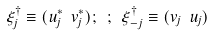Convert formula to latex. <formula><loc_0><loc_0><loc_500><loc_500>\xi ^ { \dag } _ { j } \equiv ( u ^ { * } _ { j } \ v ^ { * } _ { j } ) ; \ ; \ \xi ^ { \dag } _ { - j } \equiv ( v _ { j } \ u _ { j } )</formula> 